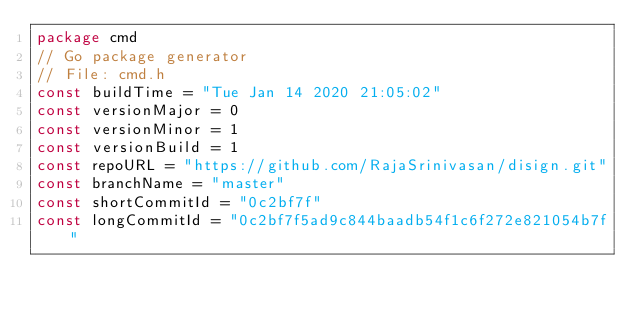<code> <loc_0><loc_0><loc_500><loc_500><_Go_>package cmd
// Go package generator
// File: cmd.h
const buildTime = "Tue Jan 14 2020 21:05:02"
const versionMajor = 0
const versionMinor = 1
const versionBuild = 1
const repoURL = "https://github.com/RajaSrinivasan/disign.git"
const branchName = "master"
const shortCommitId = "0c2bf7f"
const longCommitId = "0c2bf7f5ad9c844baadb54f1c6f272e821054b7f"
</code> 